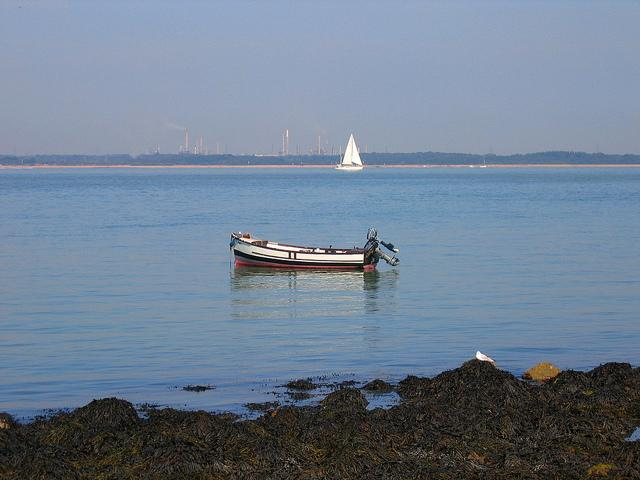What is in the background? Please explain your reasoning. sailboat. A boat with it's sails up is there. 